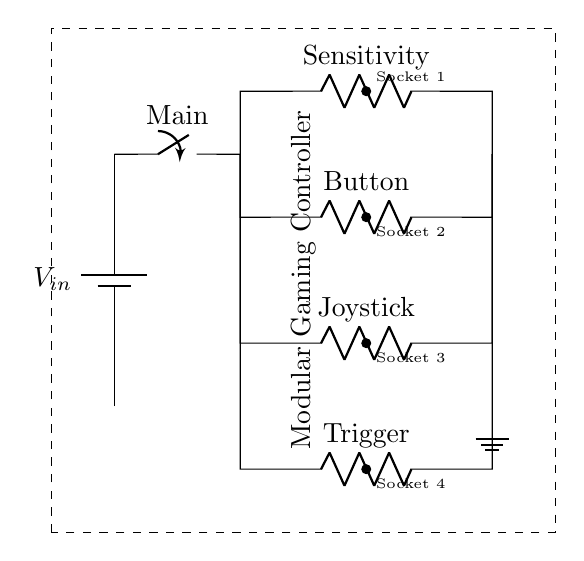What is the main function of the switch in this circuit? The switch, labeled as Main, is used to control the overall power supply to the entire circuit. When closed, it allows current to flow to all components in parallel; when open, it stops current from flowing.
Answer: Control power How many parallel branches are present in the circuit? By analyzing the diagram, there are four parallel branches, each connected to the main power before splitting into components: Sensitivity, Button, Joystick, and Trigger.
Answer: Four What does the label 'Sensitivity' refer to in the circuit? The label 'Sensitivity' identifies one of the resistive elements in the circuit that likely adjusts the response level of the modular controller, affecting how sensitive it is to user inputs.
Answer: Adjustable resistance What is the purpose of the interchangeable component sockets? The interchangeable component sockets allow for different gaming controls or attachments to be plugged in, enhancing the modularity of the gaming controller, enabling customization based on user preference.
Answer: Customization If one branch is activated, how does it affect the other branches? In a parallel circuit, activating one branch means that all the others remain unaffected in terms of voltage; they still have the same potential difference as the power supply, allowing for simultaneous use without interaction.
Answer: Unaffected 